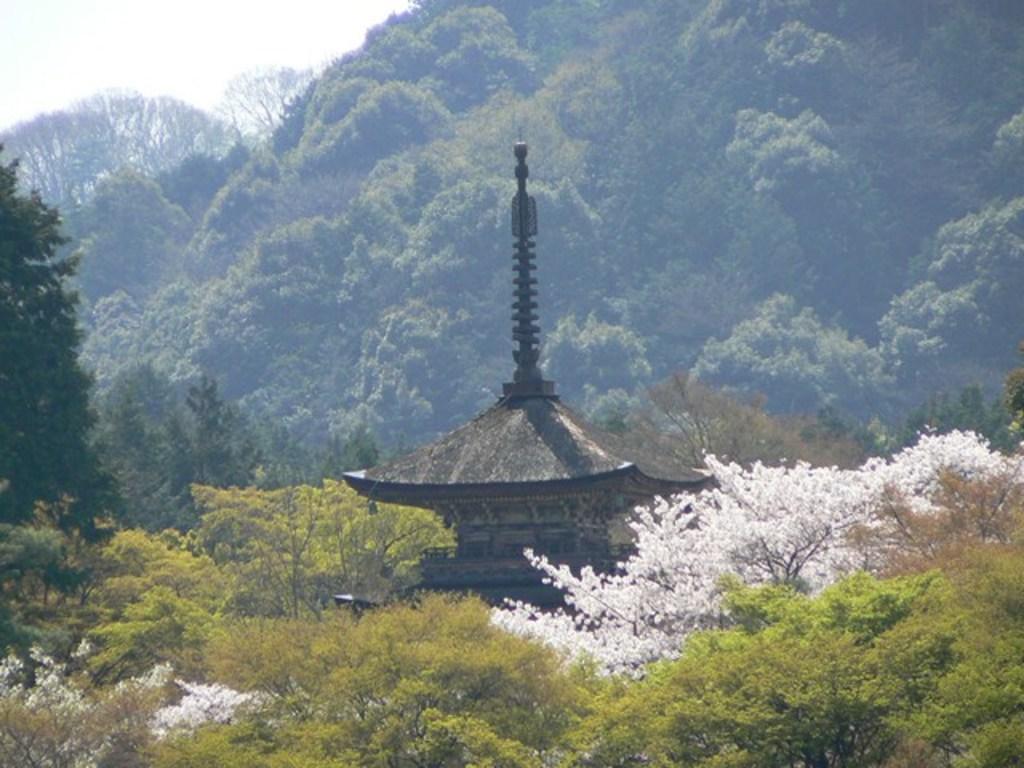Please provide a concise description of this image. In this image, I can see an ancient building and the trees. In the background, there is a mountain and the sky. 